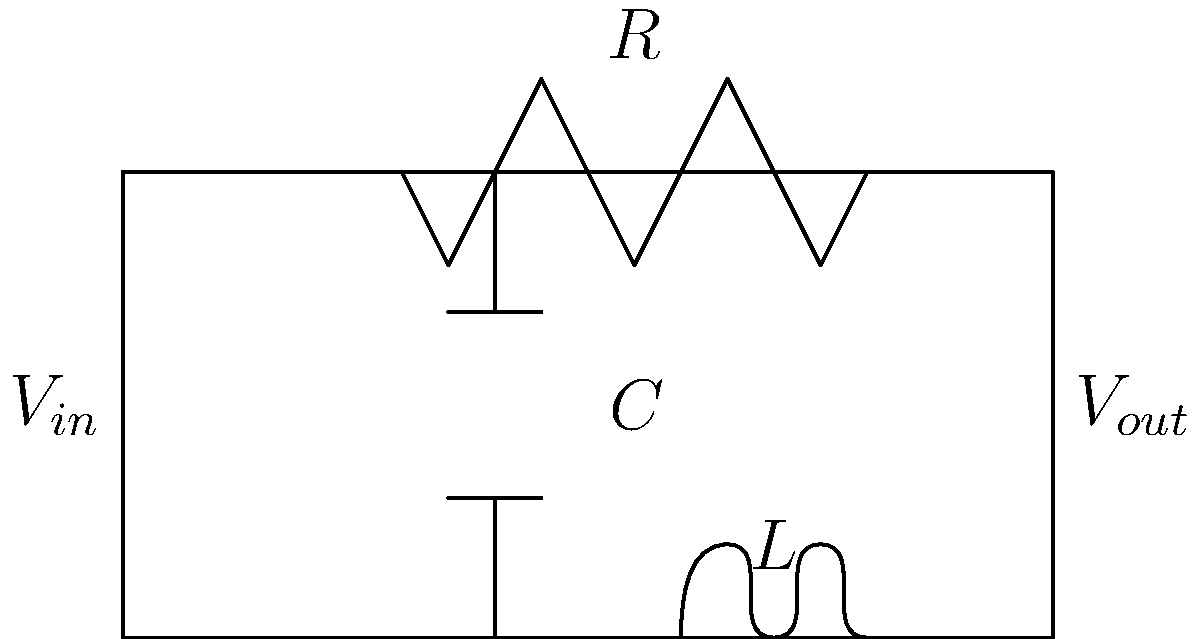In the circuit diagram above, representing an ancient maritime navigation tool, what type of filter does this configuration represent, and how might it have been used in early seafaring? To answer this question, let's analyze the circuit and its potential application in maritime navigation:

1. Circuit analysis:
   - The circuit consists of a resistor (R), capacitor (C), and inductor (L) in a specific configuration.
   - The components are arranged in a low-pass filter configuration.

2. Filter type:
   - This is a second-order low-pass filter, also known as an RLC low-pass filter.
   - Low-pass filters allow low-frequency signals to pass through while attenuating high-frequency signals.

3. Maritime navigation application:
   - In early seafaring, navigators relied on various environmental signals to determine their position and course.
   - One crucial signal was the Earth's magnetic field, which varies slowly over large distances.

4. Possible use in navigation:
   - This filter could have been part of a rudimentary compass or magnetometer system.
   - It would help isolate the low-frequency changes in the Earth's magnetic field from higher-frequency noise caused by waves, ship movement, or other electromagnetic interference.

5. Functionality:
   - The filter would smooth out rapid fluctuations in the input signal ($V_{in}$).
   - The output ($V_{out}$) would represent a more stable reading of the magnetic field direction.

6. Benefit to navigation:
   - By providing a cleaner signal, this filter would allow for more accurate compass readings.
   - Improved accuracy in determining magnetic north would lead to better navigation and increased safety for early seafarers.

In the context of anthropological study, this circuit represents an intersection of ancient maritime technology and navigation practices, showcasing how early sailors adapted electrical concepts to improve their ability to traverse the seas safely.
Answer: Low-pass filter for stabilizing compass readings 